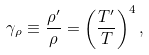<formula> <loc_0><loc_0><loc_500><loc_500>\gamma _ { \rho } \equiv \frac { \rho ^ { \prime } } { \rho } = \left ( { \frac { T ^ { \prime } } { T } } \right ) ^ { 4 } ,</formula> 